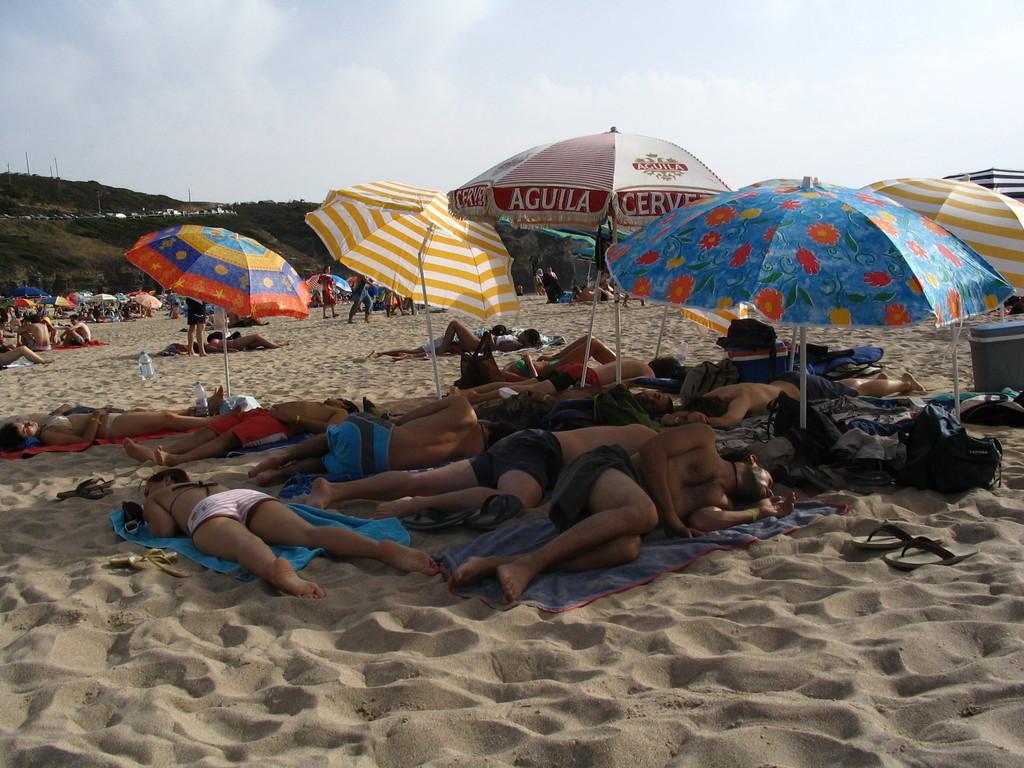Please provide a concise description of this image. In the image there are few people lying on the the sand surface and behind them some people were standing and sitting, there are few umbrellas on the sand surface. 